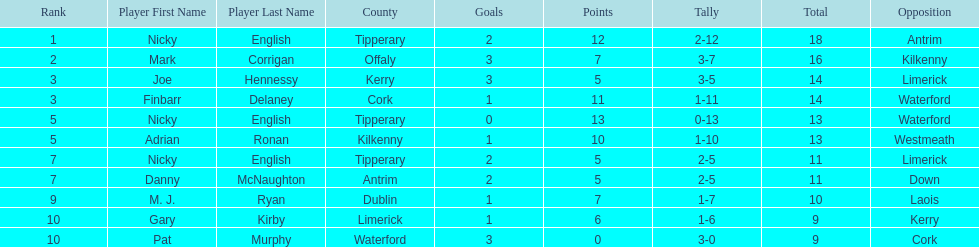What was the average of the totals of nicky english and mark corrigan? 17. 